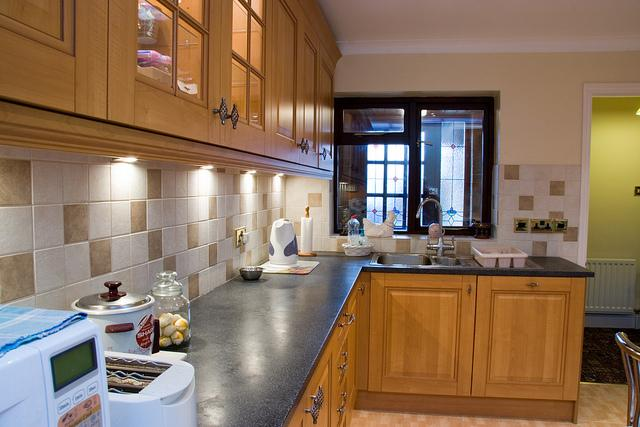What appliance is next to the microwave? toaster 